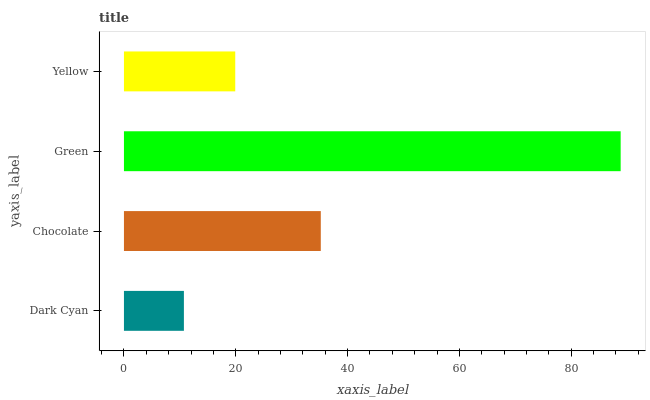Is Dark Cyan the minimum?
Answer yes or no. Yes. Is Green the maximum?
Answer yes or no. Yes. Is Chocolate the minimum?
Answer yes or no. No. Is Chocolate the maximum?
Answer yes or no. No. Is Chocolate greater than Dark Cyan?
Answer yes or no. Yes. Is Dark Cyan less than Chocolate?
Answer yes or no. Yes. Is Dark Cyan greater than Chocolate?
Answer yes or no. No. Is Chocolate less than Dark Cyan?
Answer yes or no. No. Is Chocolate the high median?
Answer yes or no. Yes. Is Yellow the low median?
Answer yes or no. Yes. Is Dark Cyan the high median?
Answer yes or no. No. Is Chocolate the low median?
Answer yes or no. No. 